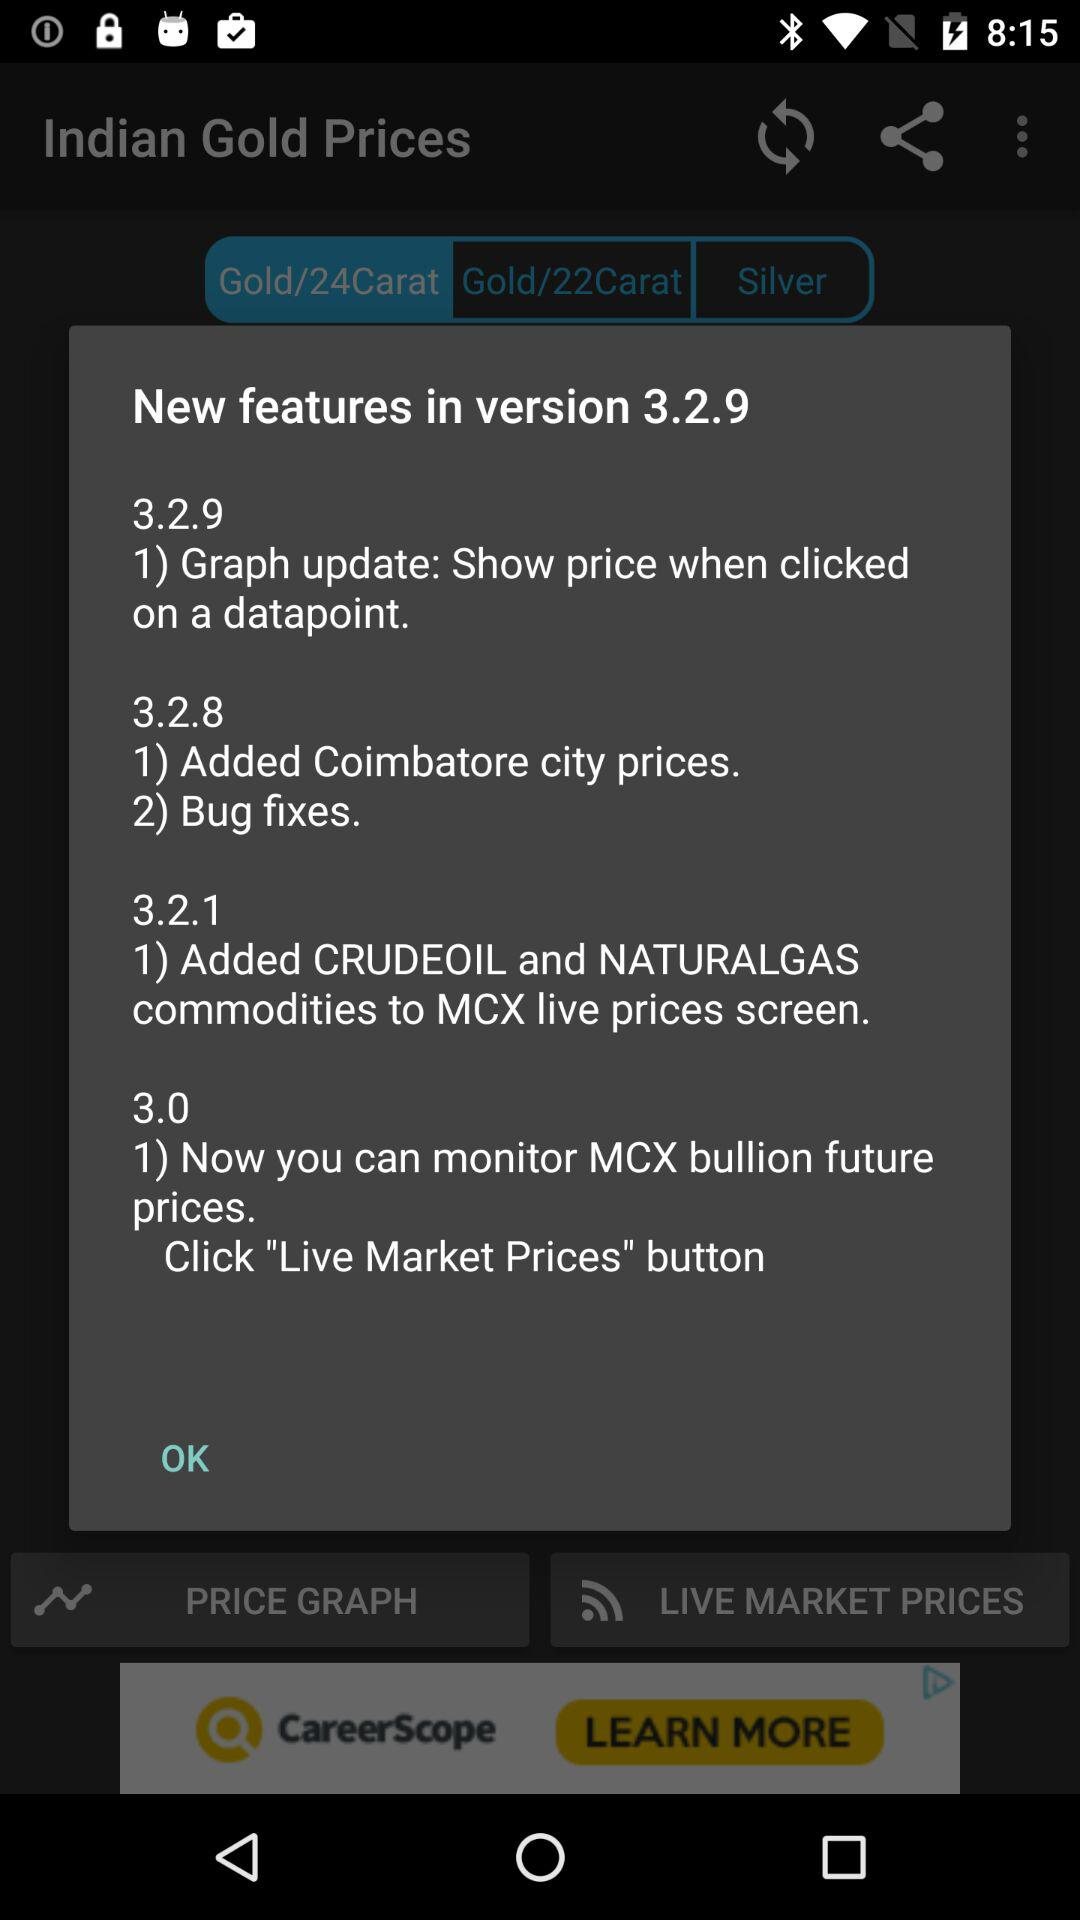What are the new features in version 3.2.8? The new features in version 3.2.8 are "Added Coimbatore city prices" and "Bug fixes". 